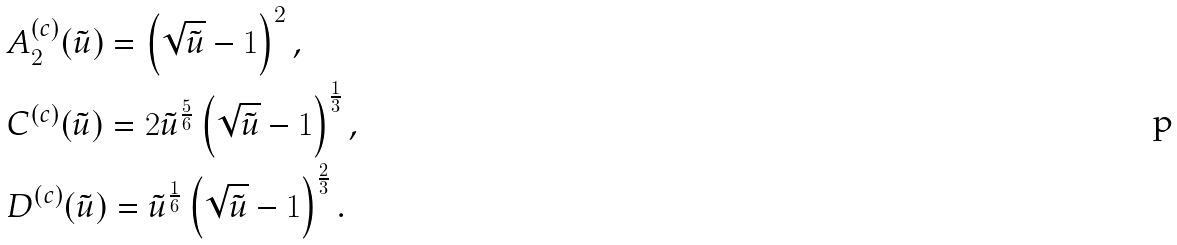Convert formula to latex. <formula><loc_0><loc_0><loc_500><loc_500>& A ^ { ( c ) } _ { 2 } ( \tilde { u } ) = \left ( \sqrt { \tilde { u } } - 1 \right ) ^ { 2 } , \\ & C ^ { ( c ) } ( \tilde { u } ) = 2 \tilde { u } ^ { \frac { 5 } { 6 } } \left ( \sqrt { \tilde { u } } - 1 \right ) ^ { \frac { 1 } { 3 } } , \\ & D ^ { ( c ) } ( \tilde { u } ) = \tilde { u } ^ { \frac { 1 } { 6 } } \left ( \sqrt { \tilde { u } } - 1 \right ) ^ { \frac { 2 } { 3 } } .</formula> 